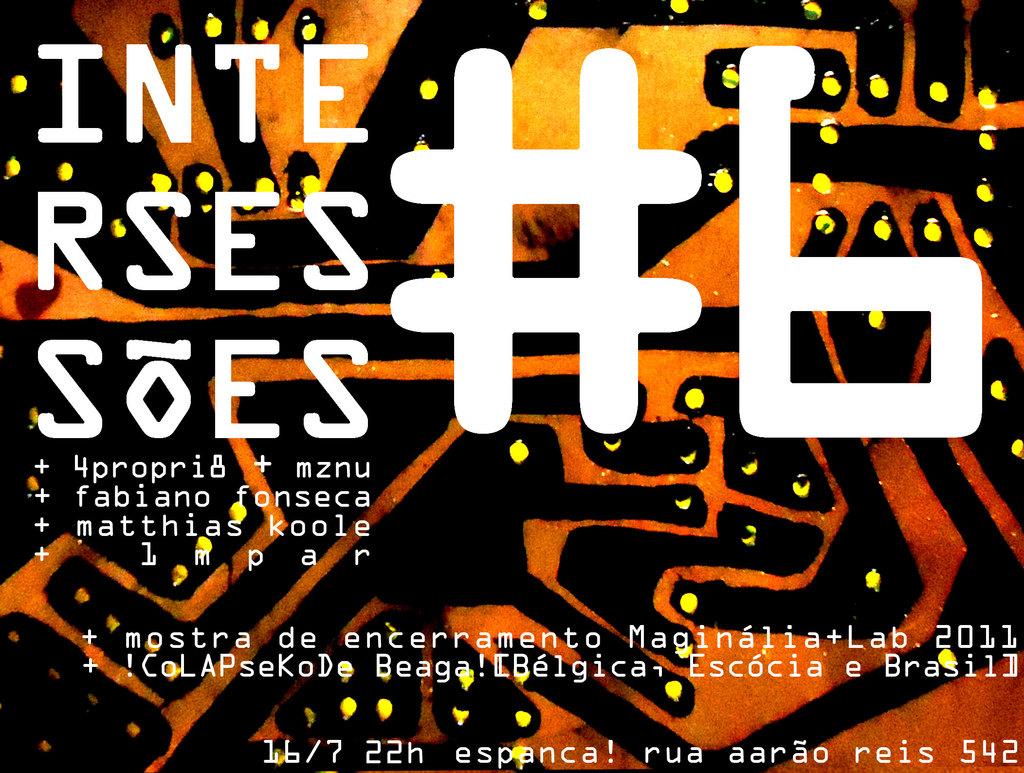What is the title of this work?
Provide a short and direct response. #6. What number is it?
Your response must be concise. 6. 